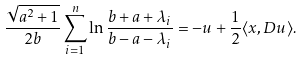<formula> <loc_0><loc_0><loc_500><loc_500>\frac { \sqrt { a ^ { 2 } + 1 } } { 2 b } \sum _ { i = 1 } ^ { n } \ln \frac { b + a + \lambda _ { i } } { b - a - \lambda _ { i } } = - u + \frac { 1 } { 2 } \langle x , D u \rangle .</formula> 